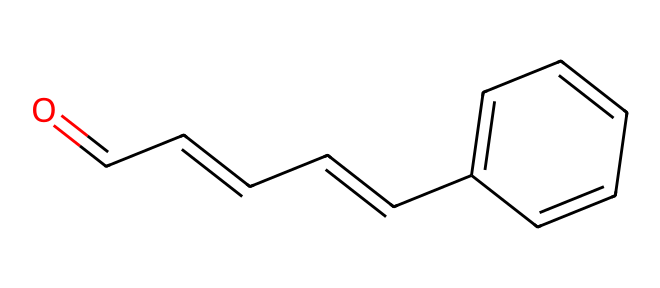What is the main functional group present in cinnamaldehyde? The molecular structure shows a carbonyl group (C=O) at the beginning of the SMILES representation, indicating the presence of an aldehyde functional group.
Answer: aldehyde How many rings are present in the structure of cinnamaldehyde? There are no circular structures in the representation; the SMILES reveals a linear structure without any ring atoms.
Answer: zero What is the molecular formula of cinnamaldehyde? By counting the carbon (C), hydrogen (H), and oxygen (O) atoms in the SMILES, we determine the formula as C9H8O.
Answer: C9H8O Which part of the molecule is most likely responsible for the aroma in cinnamon? The aromatic ring (represented by 'c' in the SMILES) is the part that accounts for the characteristic scent of cinnamon, as these structures are typically associated with many fragrant compounds.
Answer: aromatic ring How many double bonds are present in cinnamaldehyde? Counting the double bonds indicated in the SMILES (C=CC=C), there are a total of three double bonds in the structure.
Answer: three What type of chemical is cinnamaldehyde classified as? The structure’s features—especially the presence of a functional group and an aromatic component—classify cinnamaldehyde as an aromatic aldehyde.
Answer: aromatic aldehyde Does cinnamaldehyde contain any chiral centers? Analyzing the structure, there are no carbon atoms with four different substituents, indicating that there are no chiral centers in this molecule.
Answer: no 